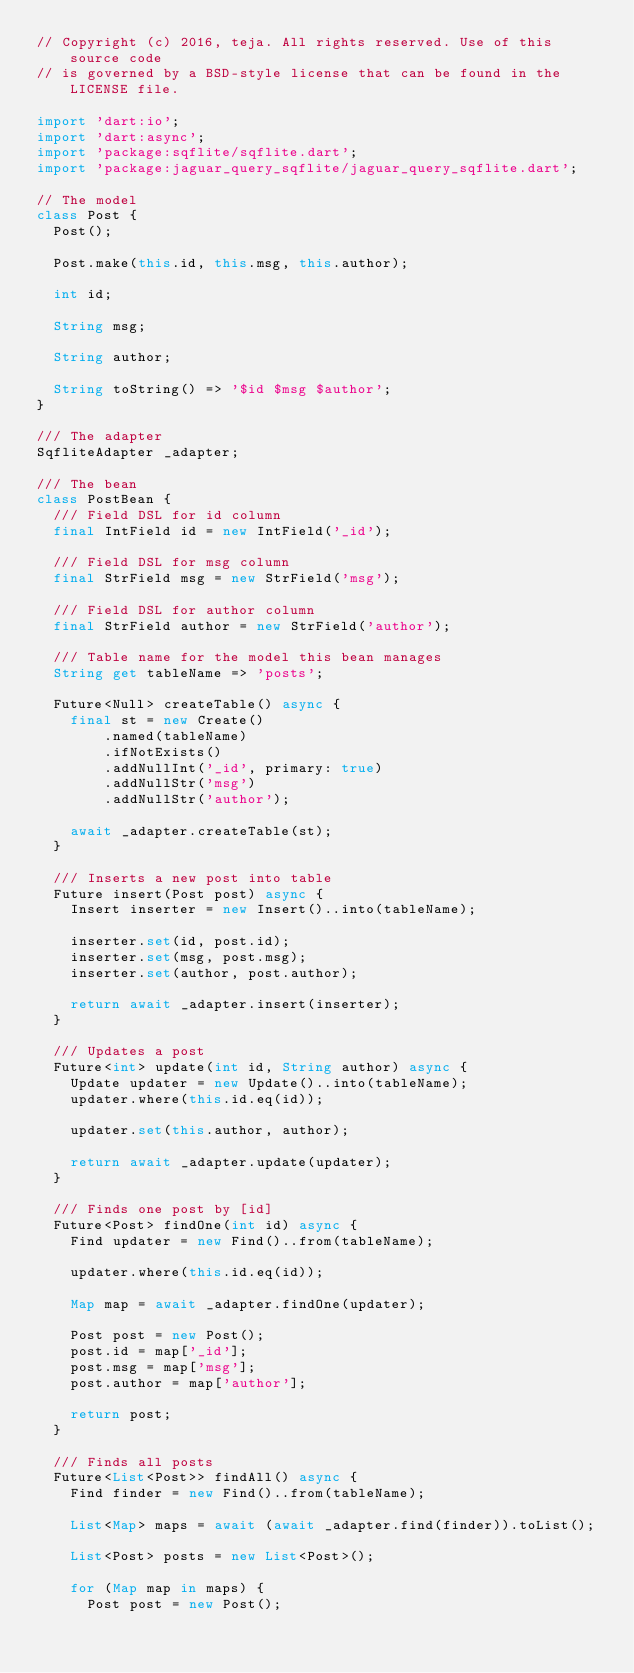Convert code to text. <code><loc_0><loc_0><loc_500><loc_500><_Dart_>// Copyright (c) 2016, teja. All rights reserved. Use of this source code
// is governed by a BSD-style license that can be found in the LICENSE file.

import 'dart:io';
import 'dart:async';
import 'package:sqflite/sqflite.dart';
import 'package:jaguar_query_sqflite/jaguar_query_sqflite.dart';

// The model
class Post {
  Post();

  Post.make(this.id, this.msg, this.author);

  int id;

  String msg;

  String author;

  String toString() => '$id $msg $author';
}

/// The adapter
SqfliteAdapter _adapter;

/// The bean
class PostBean {
  /// Field DSL for id column
  final IntField id = new IntField('_id');

  /// Field DSL for msg column
  final StrField msg = new StrField('msg');

  /// Field DSL for author column
  final StrField author = new StrField('author');

  /// Table name for the model this bean manages
  String get tableName => 'posts';

  Future<Null> createTable() async {
    final st = new Create()
        .named(tableName)
        .ifNotExists()
        .addNullInt('_id', primary: true)
        .addNullStr('msg')
        .addNullStr('author');

    await _adapter.createTable(st);
  }

  /// Inserts a new post into table
  Future insert(Post post) async {
    Insert inserter = new Insert()..into(tableName);

    inserter.set(id, post.id);
    inserter.set(msg, post.msg);
    inserter.set(author, post.author);

    return await _adapter.insert(inserter);
  }

  /// Updates a post
  Future<int> update(int id, String author) async {
    Update updater = new Update()..into(tableName);
    updater.where(this.id.eq(id));

    updater.set(this.author, author);

    return await _adapter.update(updater);
  }

  /// Finds one post by [id]
  Future<Post> findOne(int id) async {
    Find updater = new Find()..from(tableName);

    updater.where(this.id.eq(id));

    Map map = await _adapter.findOne(updater);

    Post post = new Post();
    post.id = map['_id'];
    post.msg = map['msg'];
    post.author = map['author'];

    return post;
  }

  /// Finds all posts
  Future<List<Post>> findAll() async {
    Find finder = new Find()..from(tableName);

    List<Map> maps = await (await _adapter.find(finder)).toList();

    List<Post> posts = new List<Post>();

    for (Map map in maps) {
      Post post = new Post();
</code> 